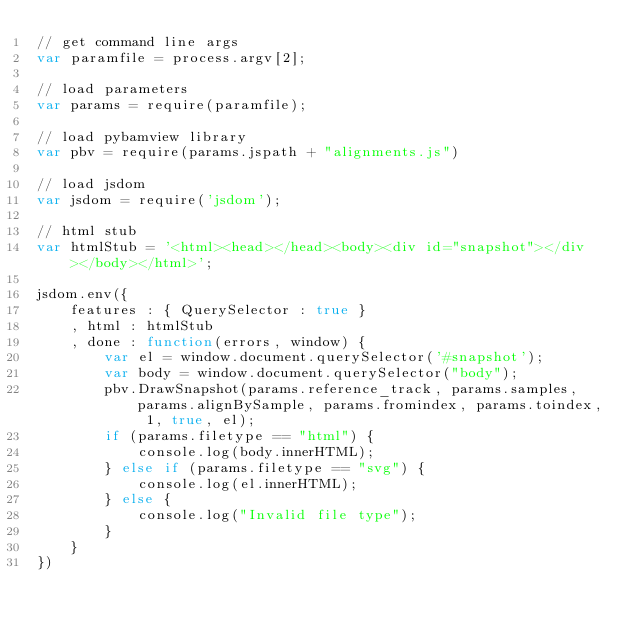<code> <loc_0><loc_0><loc_500><loc_500><_JavaScript_>// get command line args
var paramfile = process.argv[2];

// load parameters
var params = require(paramfile);

// load pybamview library
var pbv = require(params.jspath + "alignments.js")

// load jsdom
var jsdom = require('jsdom');

// html stub
var htmlStub = '<html><head></head><body><div id="snapshot"></div></body></html>';

jsdom.env({
	features : { QuerySelector : true }
	, html : htmlStub
	, done : function(errors, window) {
		var el = window.document.querySelector('#snapshot');
		var body = window.document.querySelector("body");
		pbv.DrawSnapshot(params.reference_track, params.samples, params.alignBySample, params.fromindex, params.toindex, 1, true, el);
		if (params.filetype == "html") {
			console.log(body.innerHTML);
		} else if (params.filetype == "svg") {
			console.log(el.innerHTML);
		} else {
			console.log("Invalid file type");
		}
	}
})
</code> 